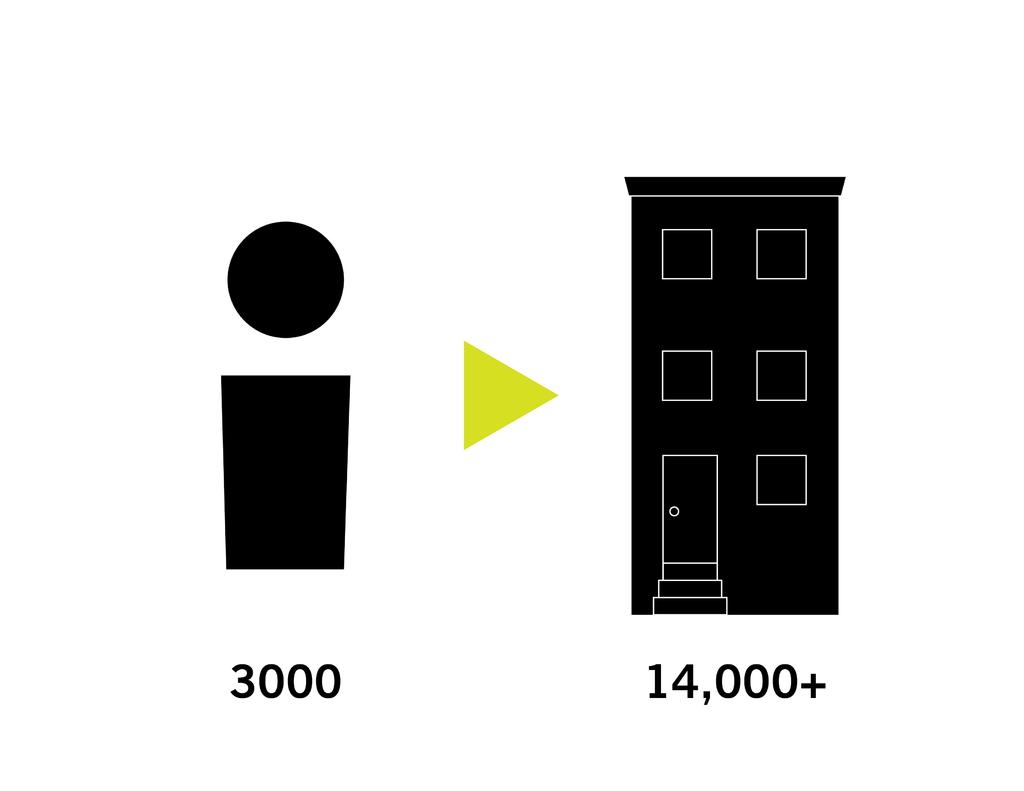<image>
Write a terse but informative summary of the picture. 3000 is written under a large black i and 14,000 + is written under a black building. 